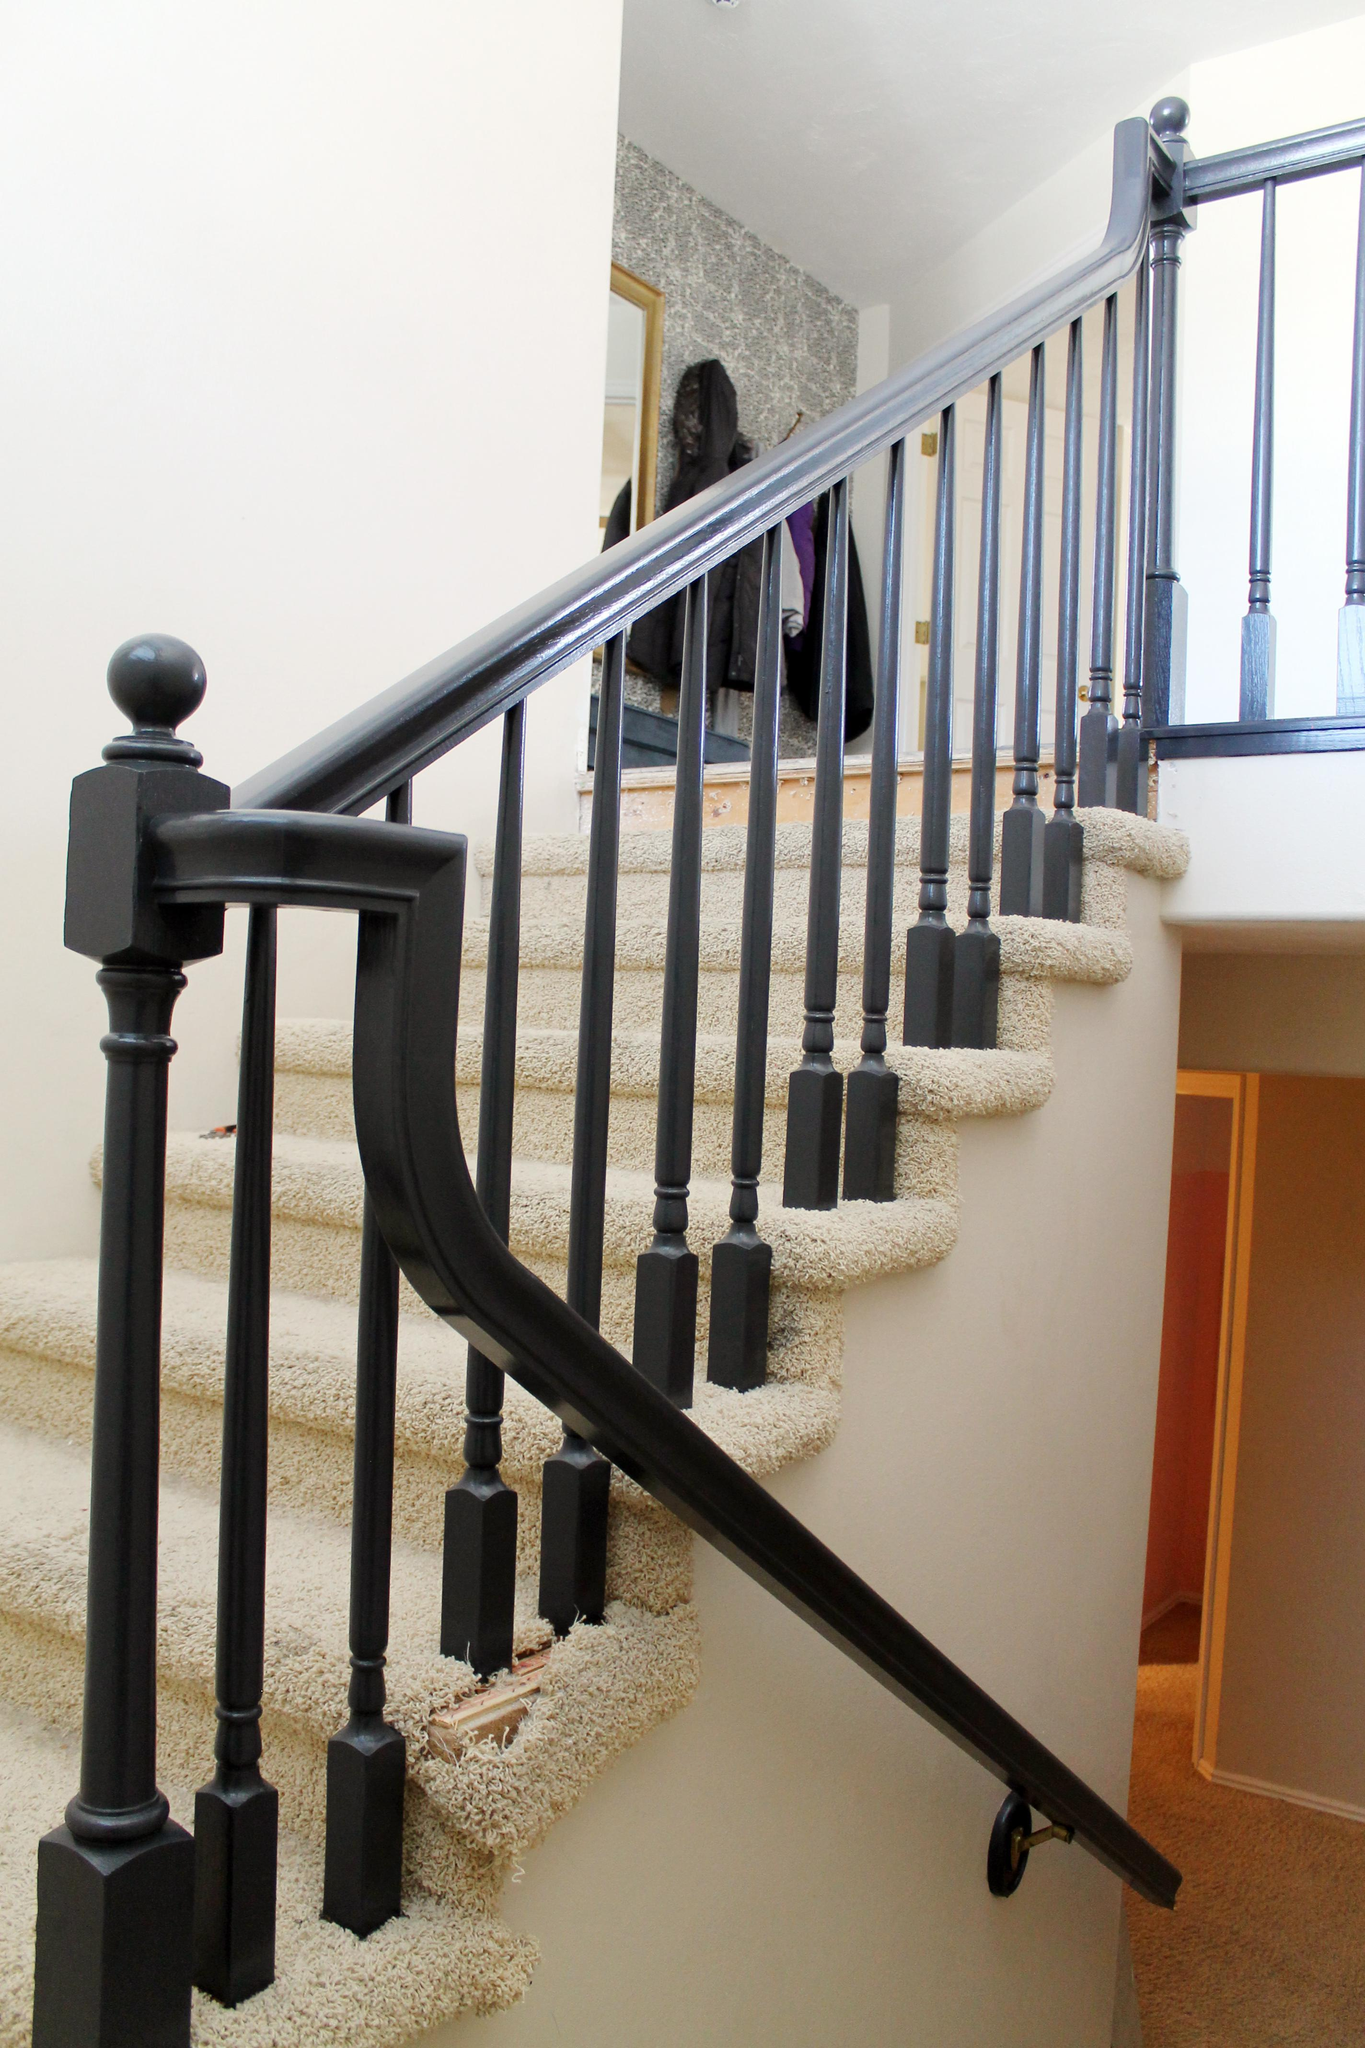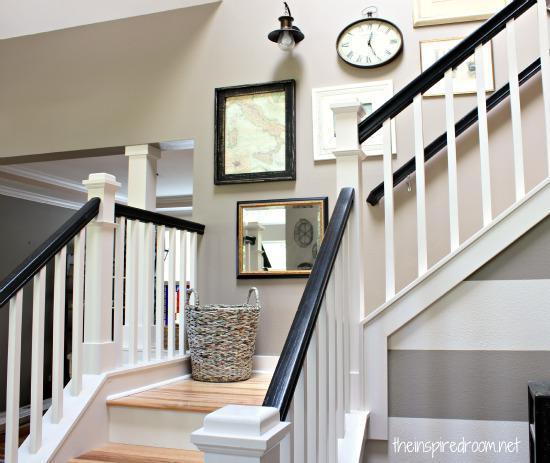The first image is the image on the left, the second image is the image on the right. For the images shown, is this caption "In at least one image a there are three picture frames showing above a single stair case that faces left with the exception of 1 to 3 individual stairs." true? Answer yes or no. No. 